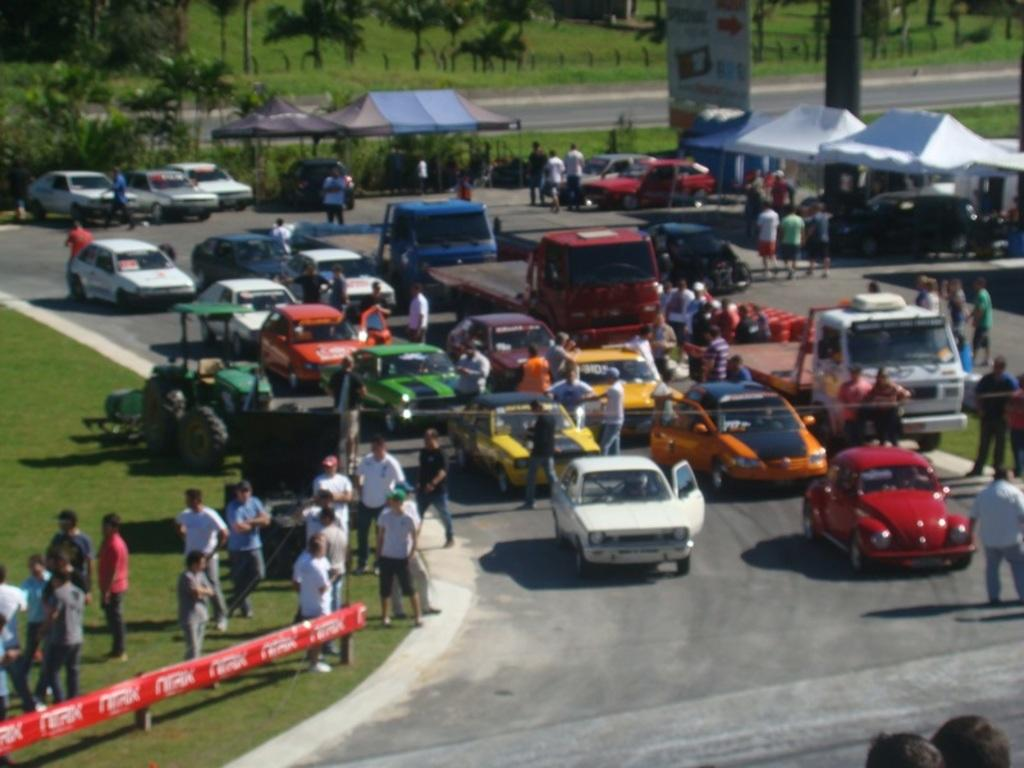What types of living organisms can be seen in the image? People and trees are visible in the image. What type of vehicles can be seen in the image? Cars can be seen in the image. What type of natural environment is visible in the image? Grass and trees are visible in the image. What type of temporary shelter is present in the image? Tents are present in the image. What type of hair can be seen on the page in the image? There is no page or hair present in the image. What type of print can be seen on the tents in the image? There is no print visible on the tents in the image. 